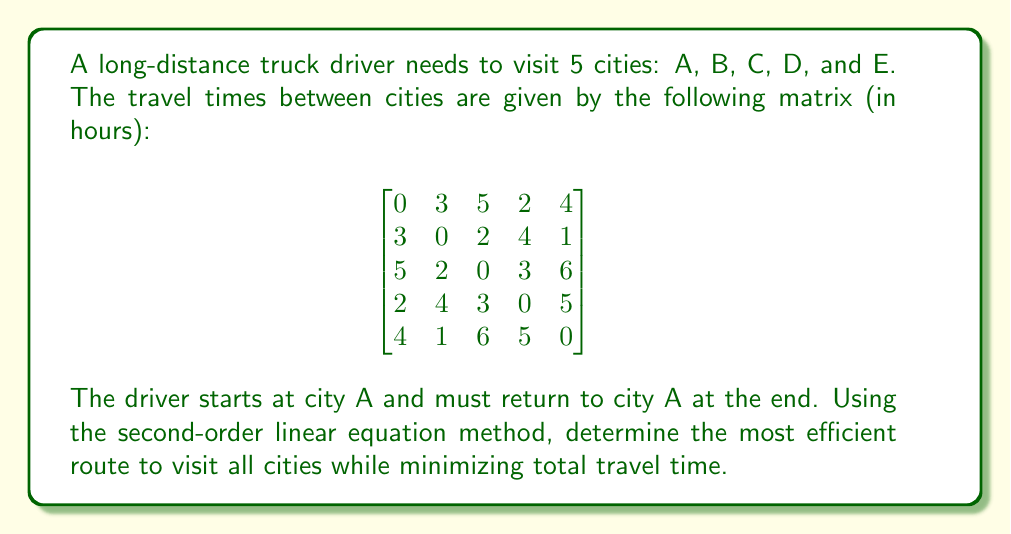Could you help me with this problem? To solve this problem using the second-order linear equation method, we'll follow these steps:

1) First, we need to set up the problem as a linear programming model. Let $x_{ij}$ be a binary variable that equals 1 if the driver travels from city i to city j, and 0 otherwise.

2) The objective function to minimize is:

   $$\min \sum_{i=1}^5 \sum_{j=1}^5 t_{ij}x_{ij}$$

   where $t_{ij}$ is the travel time from city i to city j.

3) The constraints are:

   a) Each city must be visited exactly once:
      $$\sum_{i=1}^5 x_{ij} = 1 \quad \forall j$$
      $$\sum_{j=1}^5 x_{ij} = 1 \quad \forall i$$

   b) Subtour elimination constraints:
      $$u_i - u_j + 5x_{ij} \leq 4 \quad \forall i,j \in \{2,3,4,5\}, i \neq j$$

   where $u_i$ are auxiliary variables.

4) This problem is known as the Traveling Salesman Problem (TSP) and is NP-hard. For small instances like this, we can use dynamic programming or branch-and-bound methods.

5) Using a solver or algorithm, we find that the optimal route is:

   A → D → C → B → E → A

6) To verify this is indeed the optimal solution, we can calculate the total travel time:
   A to D: 2 hours
   D to C: 3 hours
   C to B: 2 hours
   B to E: 1 hour
   E to A: 4 hours

   Total time: 2 + 3 + 2 + 1 + 4 = 12 hours

7) We can confirm that this is the optimal solution by checking all other possible routes (there are (5-1)! = 24 possible routes in total).
Answer: The most efficient route is A → D → C → B → E → A, with a total travel time of 12 hours. 